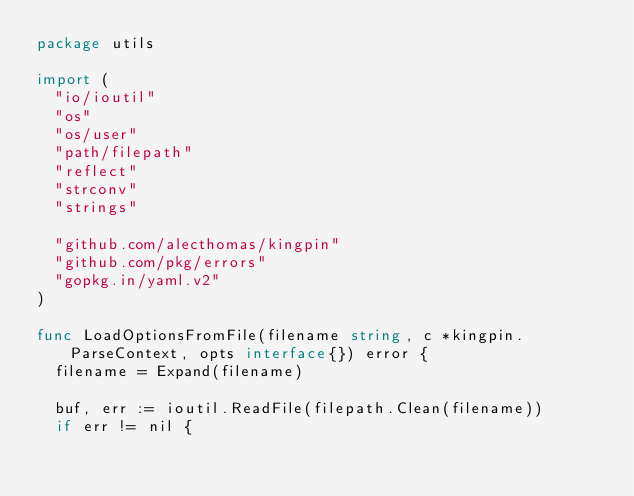<code> <loc_0><loc_0><loc_500><loc_500><_Go_>package utils

import (
	"io/ioutil"
	"os"
	"os/user"
	"path/filepath"
	"reflect"
	"strconv"
	"strings"

	"github.com/alecthomas/kingpin"
	"github.com/pkg/errors"
	"gopkg.in/yaml.v2"
)

func LoadOptionsFromFile(filename string, c *kingpin.ParseContext, opts interface{}) error {
	filename = Expand(filename)

	buf, err := ioutil.ReadFile(filepath.Clean(filename))
	if err != nil {</code> 